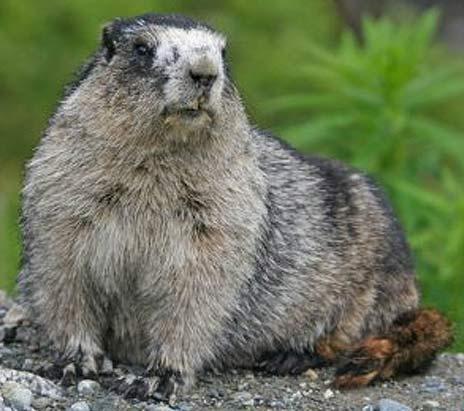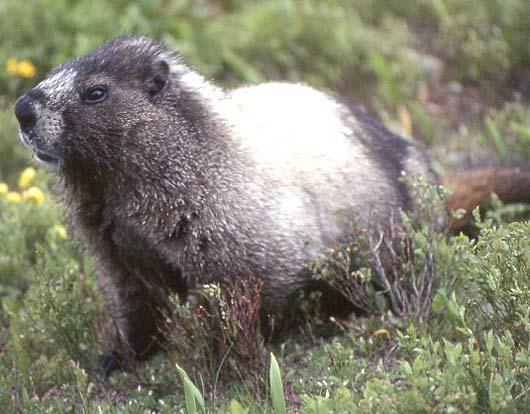The first image is the image on the left, the second image is the image on the right. Given the left and right images, does the statement "There are two ground hogs perched high on a rock." hold true? Answer yes or no. No. The first image is the image on the left, the second image is the image on the right. Assess this claim about the two images: "One of the groundhogs is near yellow flowers.". Correct or not? Answer yes or no. Yes. 